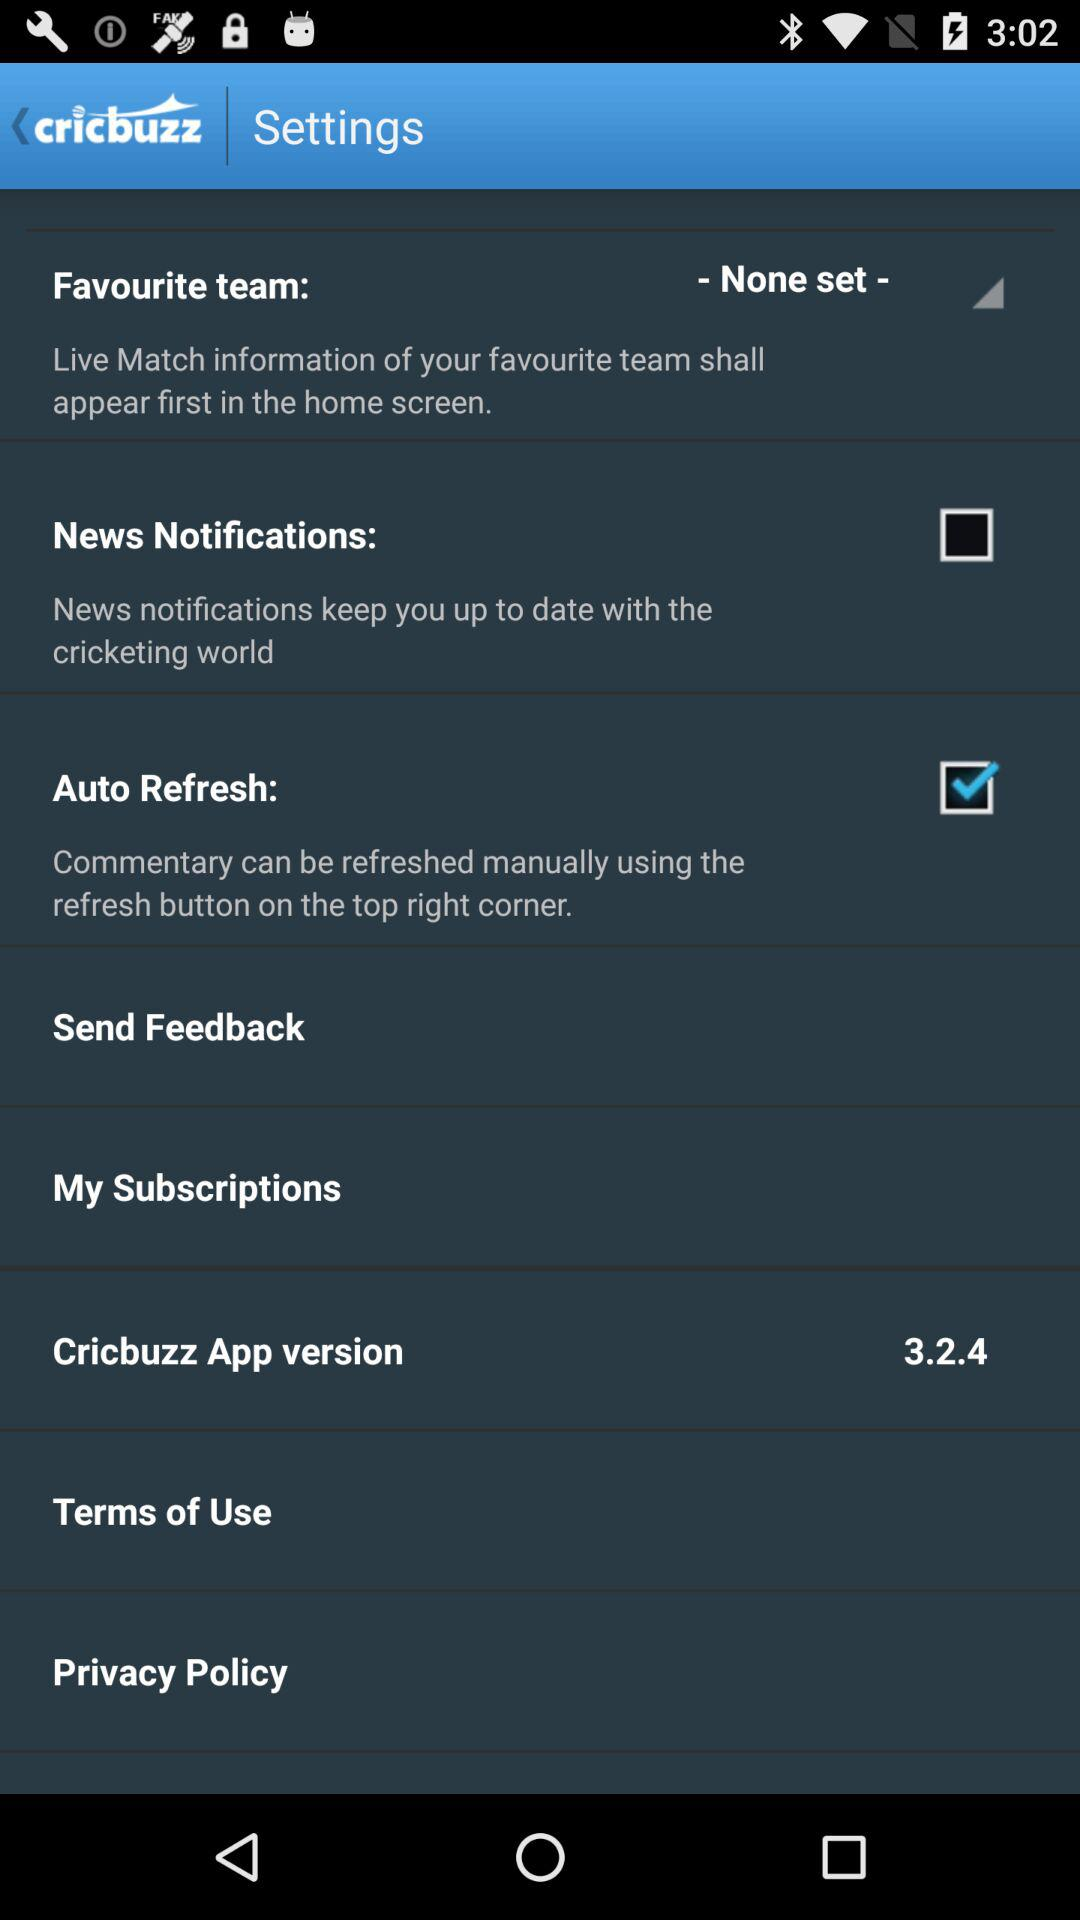How many items have check boxes?
Answer the question using a single word or phrase. 2 